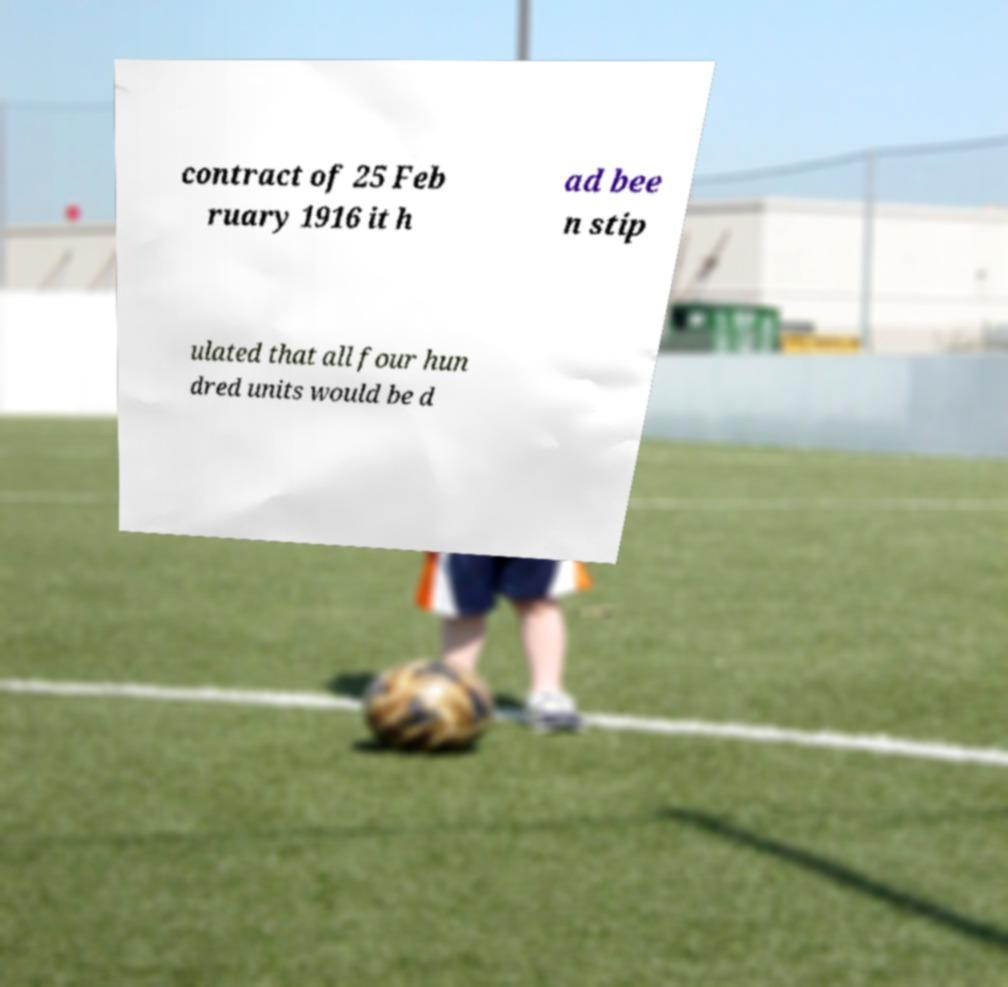For documentation purposes, I need the text within this image transcribed. Could you provide that? contract of 25 Feb ruary 1916 it h ad bee n stip ulated that all four hun dred units would be d 